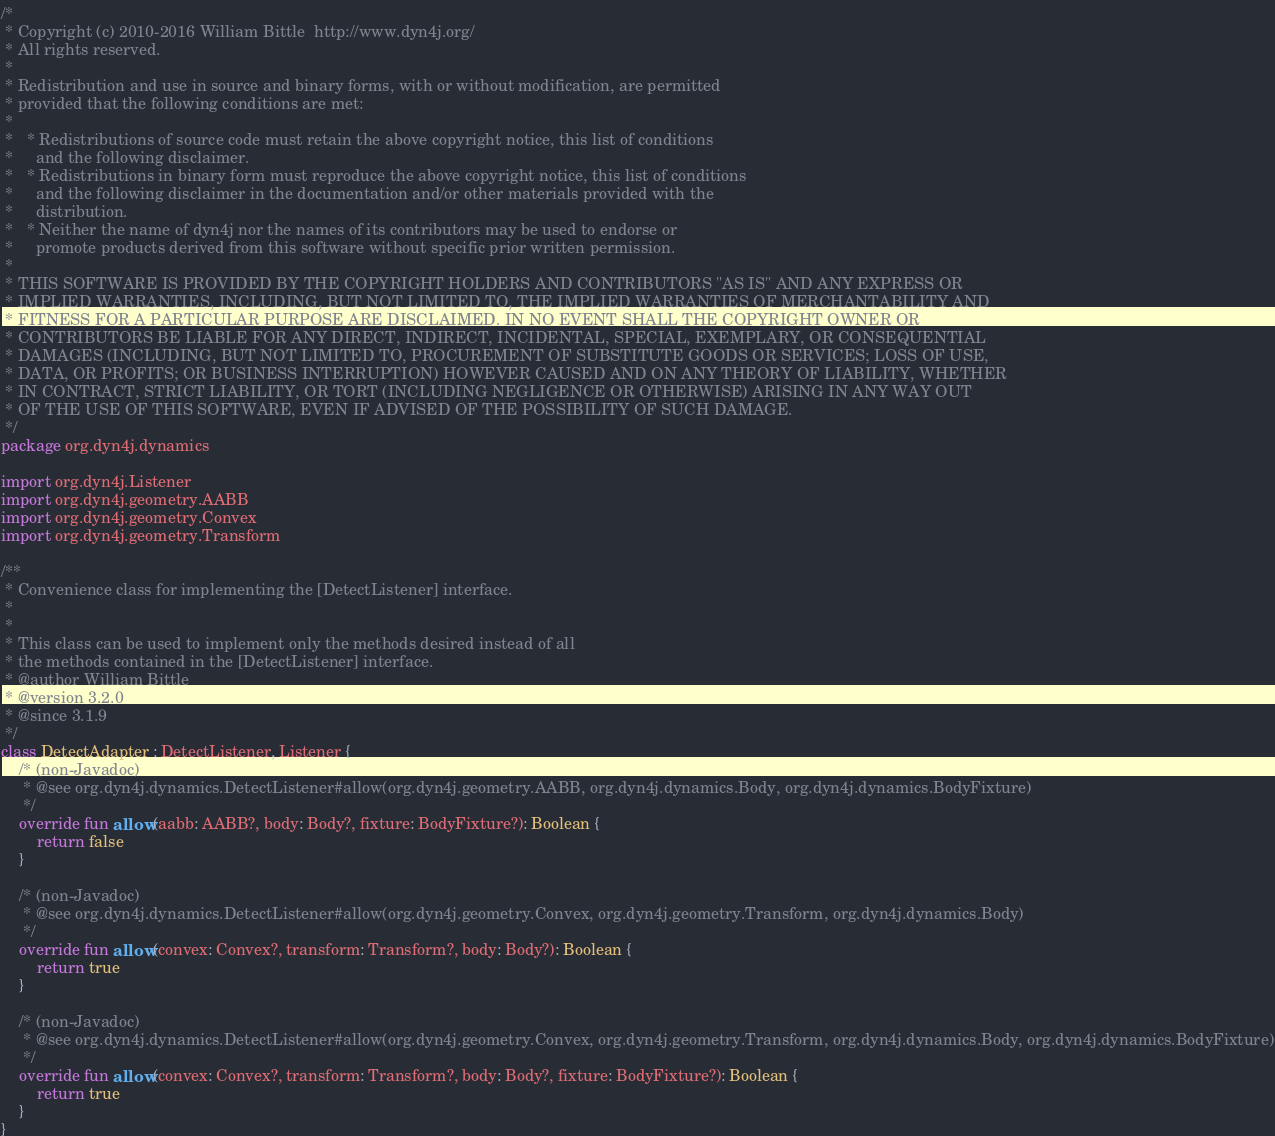Convert code to text. <code><loc_0><loc_0><loc_500><loc_500><_Kotlin_>/*
 * Copyright (c) 2010-2016 William Bittle  http://www.dyn4j.org/
 * All rights reserved.
 * 
 * Redistribution and use in source and binary forms, with or without modification, are permitted 
 * provided that the following conditions are met:
 * 
 *   * Redistributions of source code must retain the above copyright notice, this list of conditions 
 *     and the following disclaimer.
 *   * Redistributions in binary form must reproduce the above copyright notice, this list of conditions 
 *     and the following disclaimer in the documentation and/or other materials provided with the 
 *     distribution.
 *   * Neither the name of dyn4j nor the names of its contributors may be used to endorse or 
 *     promote products derived from this software without specific prior written permission.
 * 
 * THIS SOFTWARE IS PROVIDED BY THE COPYRIGHT HOLDERS AND CONTRIBUTORS "AS IS" AND ANY EXPRESS OR 
 * IMPLIED WARRANTIES, INCLUDING, BUT NOT LIMITED TO, THE IMPLIED WARRANTIES OF MERCHANTABILITY AND 
 * FITNESS FOR A PARTICULAR PURPOSE ARE DISCLAIMED. IN NO EVENT SHALL THE COPYRIGHT OWNER OR 
 * CONTRIBUTORS BE LIABLE FOR ANY DIRECT, INDIRECT, INCIDENTAL, SPECIAL, EXEMPLARY, OR CONSEQUENTIAL 
 * DAMAGES (INCLUDING, BUT NOT LIMITED TO, PROCUREMENT OF SUBSTITUTE GOODS OR SERVICES; LOSS OF USE, 
 * DATA, OR PROFITS; OR BUSINESS INTERRUPTION) HOWEVER CAUSED AND ON ANY THEORY OF LIABILITY, WHETHER 
 * IN CONTRACT, STRICT LIABILITY, OR TORT (INCLUDING NEGLIGENCE OR OTHERWISE) ARISING IN ANY WAY OUT 
 * OF THE USE OF THIS SOFTWARE, EVEN IF ADVISED OF THE POSSIBILITY OF SUCH DAMAGE.
 */
package org.dyn4j.dynamics

import org.dyn4j.Listener
import org.dyn4j.geometry.AABB
import org.dyn4j.geometry.Convex
import org.dyn4j.geometry.Transform

/**
 * Convenience class for implementing the [DetectListener] interface.
 *
 *
 * This class can be used to implement only the methods desired instead of all
 * the methods contained in the [DetectListener] interface.
 * @author William Bittle
 * @version 3.2.0
 * @since 3.1.9
 */
class DetectAdapter : DetectListener, Listener {
    /* (non-Javadoc)
	 * @see org.dyn4j.dynamics.DetectListener#allow(org.dyn4j.geometry.AABB, org.dyn4j.dynamics.Body, org.dyn4j.dynamics.BodyFixture)
	 */
    override fun allow(aabb: AABB?, body: Body?, fixture: BodyFixture?): Boolean {
        return false
    }

    /* (non-Javadoc)
	 * @see org.dyn4j.dynamics.DetectListener#allow(org.dyn4j.geometry.Convex, org.dyn4j.geometry.Transform, org.dyn4j.dynamics.Body)
	 */
    override fun allow(convex: Convex?, transform: Transform?, body: Body?): Boolean {
        return true
    }

    /* (non-Javadoc)
	 * @see org.dyn4j.dynamics.DetectListener#allow(org.dyn4j.geometry.Convex, org.dyn4j.geometry.Transform, org.dyn4j.dynamics.Body, org.dyn4j.dynamics.BodyFixture)
	 */
    override fun allow(convex: Convex?, transform: Transform?, body: Body?, fixture: BodyFixture?): Boolean {
        return true
    }
}</code> 